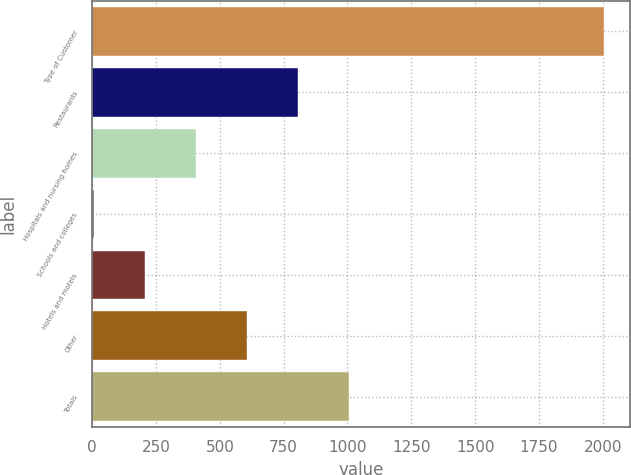<chart> <loc_0><loc_0><loc_500><loc_500><bar_chart><fcel>Type of Customer<fcel>Restaurants<fcel>Hospitals and nursing homes<fcel>Schools and colleges<fcel>Hotels and motels<fcel>Other<fcel>Totals<nl><fcel>2006<fcel>805.4<fcel>405.2<fcel>5<fcel>205.1<fcel>605.3<fcel>1005.5<nl></chart> 